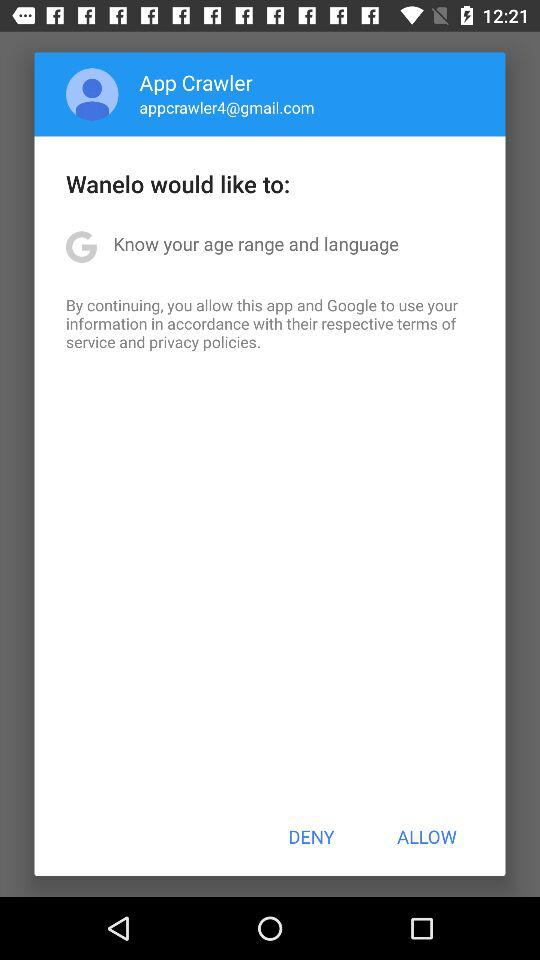What is the email address? The email address is appcrawler4@gmail.com. 